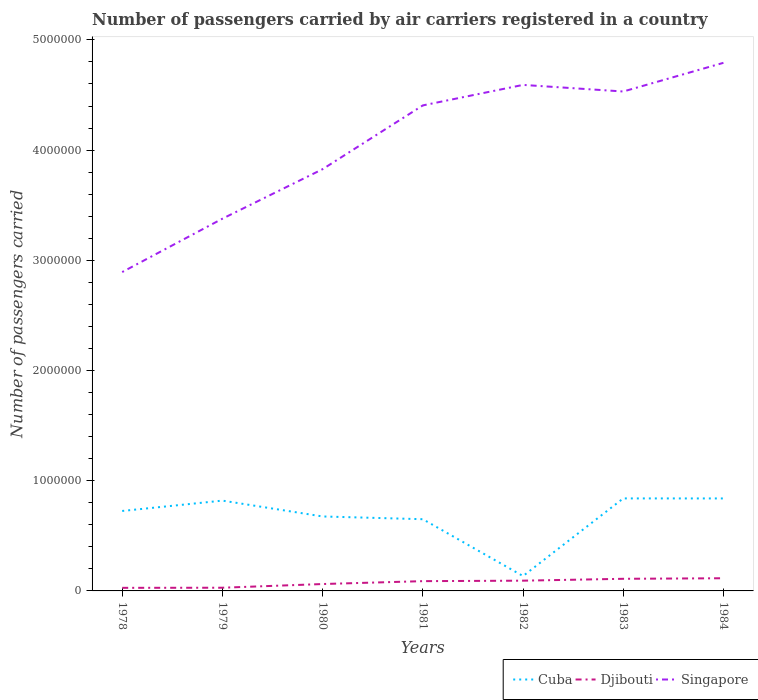Is the number of lines equal to the number of legend labels?
Your answer should be very brief. Yes. Across all years, what is the maximum number of passengers carried by air carriers in Cuba?
Provide a succinct answer. 1.35e+05. What is the total number of passengers carried by air carriers in Singapore in the graph?
Offer a terse response. -1.03e+06. What is the difference between the highest and the second highest number of passengers carried by air carriers in Djibouti?
Keep it short and to the point. 8.70e+04. Is the number of passengers carried by air carriers in Singapore strictly greater than the number of passengers carried by air carriers in Cuba over the years?
Your answer should be compact. No. How many lines are there?
Your answer should be compact. 3. Are the values on the major ticks of Y-axis written in scientific E-notation?
Provide a short and direct response. No. Does the graph contain grids?
Offer a terse response. No. How many legend labels are there?
Give a very brief answer. 3. What is the title of the graph?
Your response must be concise. Number of passengers carried by air carriers registered in a country. Does "St. Martin (French part)" appear as one of the legend labels in the graph?
Make the answer very short. No. What is the label or title of the Y-axis?
Your response must be concise. Number of passengers carried. What is the Number of passengers carried in Cuba in 1978?
Give a very brief answer. 7.26e+05. What is the Number of passengers carried of Djibouti in 1978?
Your answer should be very brief. 2.80e+04. What is the Number of passengers carried of Singapore in 1978?
Offer a very short reply. 2.89e+06. What is the Number of passengers carried of Cuba in 1979?
Make the answer very short. 8.19e+05. What is the Number of passengers carried of Djibouti in 1979?
Provide a succinct answer. 2.90e+04. What is the Number of passengers carried in Singapore in 1979?
Your answer should be compact. 3.38e+06. What is the Number of passengers carried in Cuba in 1980?
Keep it short and to the point. 6.76e+05. What is the Number of passengers carried in Djibouti in 1980?
Make the answer very short. 6.25e+04. What is the Number of passengers carried in Singapore in 1980?
Your answer should be compact. 3.83e+06. What is the Number of passengers carried in Cuba in 1981?
Give a very brief answer. 6.51e+05. What is the Number of passengers carried in Djibouti in 1981?
Make the answer very short. 8.87e+04. What is the Number of passengers carried of Singapore in 1981?
Your answer should be compact. 4.41e+06. What is the Number of passengers carried in Cuba in 1982?
Your response must be concise. 1.35e+05. What is the Number of passengers carried in Djibouti in 1982?
Your response must be concise. 9.30e+04. What is the Number of passengers carried of Singapore in 1982?
Offer a very short reply. 4.59e+06. What is the Number of passengers carried in Cuba in 1983?
Keep it short and to the point. 8.39e+05. What is the Number of passengers carried in Singapore in 1983?
Offer a terse response. 4.53e+06. What is the Number of passengers carried of Cuba in 1984?
Provide a succinct answer. 8.39e+05. What is the Number of passengers carried in Djibouti in 1984?
Give a very brief answer. 1.15e+05. What is the Number of passengers carried in Singapore in 1984?
Keep it short and to the point. 4.79e+06. Across all years, what is the maximum Number of passengers carried in Cuba?
Ensure brevity in your answer.  8.39e+05. Across all years, what is the maximum Number of passengers carried of Djibouti?
Your response must be concise. 1.15e+05. Across all years, what is the maximum Number of passengers carried in Singapore?
Give a very brief answer. 4.79e+06. Across all years, what is the minimum Number of passengers carried of Cuba?
Provide a short and direct response. 1.35e+05. Across all years, what is the minimum Number of passengers carried of Djibouti?
Your answer should be very brief. 2.80e+04. Across all years, what is the minimum Number of passengers carried in Singapore?
Give a very brief answer. 2.89e+06. What is the total Number of passengers carried in Cuba in the graph?
Provide a succinct answer. 4.68e+06. What is the total Number of passengers carried in Djibouti in the graph?
Offer a very short reply. 5.26e+05. What is the total Number of passengers carried in Singapore in the graph?
Provide a short and direct response. 2.84e+07. What is the difference between the Number of passengers carried of Cuba in 1978 and that in 1979?
Provide a succinct answer. -9.39e+04. What is the difference between the Number of passengers carried of Djibouti in 1978 and that in 1979?
Give a very brief answer. -1000. What is the difference between the Number of passengers carried of Singapore in 1978 and that in 1979?
Your answer should be compact. -4.84e+05. What is the difference between the Number of passengers carried in Cuba in 1978 and that in 1980?
Offer a terse response. 4.99e+04. What is the difference between the Number of passengers carried in Djibouti in 1978 and that in 1980?
Offer a very short reply. -3.45e+04. What is the difference between the Number of passengers carried of Singapore in 1978 and that in 1980?
Give a very brief answer. -9.34e+05. What is the difference between the Number of passengers carried of Cuba in 1978 and that in 1981?
Your answer should be very brief. 7.48e+04. What is the difference between the Number of passengers carried of Djibouti in 1978 and that in 1981?
Your answer should be compact. -6.07e+04. What is the difference between the Number of passengers carried of Singapore in 1978 and that in 1981?
Give a very brief answer. -1.51e+06. What is the difference between the Number of passengers carried of Cuba in 1978 and that in 1982?
Make the answer very short. 5.90e+05. What is the difference between the Number of passengers carried of Djibouti in 1978 and that in 1982?
Offer a very short reply. -6.50e+04. What is the difference between the Number of passengers carried in Singapore in 1978 and that in 1982?
Your answer should be very brief. -1.70e+06. What is the difference between the Number of passengers carried of Cuba in 1978 and that in 1983?
Your answer should be very brief. -1.14e+05. What is the difference between the Number of passengers carried of Djibouti in 1978 and that in 1983?
Offer a very short reply. -8.20e+04. What is the difference between the Number of passengers carried of Singapore in 1978 and that in 1983?
Provide a succinct answer. -1.64e+06. What is the difference between the Number of passengers carried of Cuba in 1978 and that in 1984?
Your response must be concise. -1.14e+05. What is the difference between the Number of passengers carried in Djibouti in 1978 and that in 1984?
Keep it short and to the point. -8.70e+04. What is the difference between the Number of passengers carried in Singapore in 1978 and that in 1984?
Provide a succinct answer. -1.90e+06. What is the difference between the Number of passengers carried of Cuba in 1979 and that in 1980?
Offer a terse response. 1.44e+05. What is the difference between the Number of passengers carried of Djibouti in 1979 and that in 1980?
Offer a very short reply. -3.35e+04. What is the difference between the Number of passengers carried of Singapore in 1979 and that in 1980?
Provide a succinct answer. -4.49e+05. What is the difference between the Number of passengers carried in Cuba in 1979 and that in 1981?
Keep it short and to the point. 1.69e+05. What is the difference between the Number of passengers carried in Djibouti in 1979 and that in 1981?
Your response must be concise. -5.97e+04. What is the difference between the Number of passengers carried in Singapore in 1979 and that in 1981?
Give a very brief answer. -1.03e+06. What is the difference between the Number of passengers carried in Cuba in 1979 and that in 1982?
Provide a short and direct response. 6.84e+05. What is the difference between the Number of passengers carried of Djibouti in 1979 and that in 1982?
Provide a short and direct response. -6.40e+04. What is the difference between the Number of passengers carried of Singapore in 1979 and that in 1982?
Give a very brief answer. -1.21e+06. What is the difference between the Number of passengers carried in Cuba in 1979 and that in 1983?
Provide a short and direct response. -2.00e+04. What is the difference between the Number of passengers carried in Djibouti in 1979 and that in 1983?
Your response must be concise. -8.10e+04. What is the difference between the Number of passengers carried of Singapore in 1979 and that in 1983?
Make the answer very short. -1.15e+06. What is the difference between the Number of passengers carried in Cuba in 1979 and that in 1984?
Your response must be concise. -1.97e+04. What is the difference between the Number of passengers carried of Djibouti in 1979 and that in 1984?
Make the answer very short. -8.60e+04. What is the difference between the Number of passengers carried in Singapore in 1979 and that in 1984?
Provide a short and direct response. -1.41e+06. What is the difference between the Number of passengers carried of Cuba in 1980 and that in 1981?
Your answer should be compact. 2.49e+04. What is the difference between the Number of passengers carried of Djibouti in 1980 and that in 1981?
Your answer should be compact. -2.62e+04. What is the difference between the Number of passengers carried of Singapore in 1980 and that in 1981?
Keep it short and to the point. -5.78e+05. What is the difference between the Number of passengers carried in Cuba in 1980 and that in 1982?
Provide a succinct answer. 5.41e+05. What is the difference between the Number of passengers carried of Djibouti in 1980 and that in 1982?
Your answer should be very brief. -3.05e+04. What is the difference between the Number of passengers carried in Singapore in 1980 and that in 1982?
Make the answer very short. -7.65e+05. What is the difference between the Number of passengers carried of Cuba in 1980 and that in 1983?
Your answer should be compact. -1.64e+05. What is the difference between the Number of passengers carried in Djibouti in 1980 and that in 1983?
Ensure brevity in your answer.  -4.75e+04. What is the difference between the Number of passengers carried of Singapore in 1980 and that in 1983?
Offer a very short reply. -7.05e+05. What is the difference between the Number of passengers carried of Cuba in 1980 and that in 1984?
Provide a short and direct response. -1.64e+05. What is the difference between the Number of passengers carried of Djibouti in 1980 and that in 1984?
Your response must be concise. -5.25e+04. What is the difference between the Number of passengers carried in Singapore in 1980 and that in 1984?
Your answer should be very brief. -9.65e+05. What is the difference between the Number of passengers carried in Cuba in 1981 and that in 1982?
Provide a short and direct response. 5.16e+05. What is the difference between the Number of passengers carried in Djibouti in 1981 and that in 1982?
Your answer should be compact. -4300. What is the difference between the Number of passengers carried in Singapore in 1981 and that in 1982?
Your answer should be very brief. -1.86e+05. What is the difference between the Number of passengers carried of Cuba in 1981 and that in 1983?
Keep it short and to the point. -1.89e+05. What is the difference between the Number of passengers carried in Djibouti in 1981 and that in 1983?
Provide a succinct answer. -2.13e+04. What is the difference between the Number of passengers carried of Singapore in 1981 and that in 1983?
Provide a succinct answer. -1.26e+05. What is the difference between the Number of passengers carried of Cuba in 1981 and that in 1984?
Provide a short and direct response. -1.88e+05. What is the difference between the Number of passengers carried of Djibouti in 1981 and that in 1984?
Your answer should be compact. -2.63e+04. What is the difference between the Number of passengers carried of Singapore in 1981 and that in 1984?
Ensure brevity in your answer.  -3.86e+05. What is the difference between the Number of passengers carried of Cuba in 1982 and that in 1983?
Give a very brief answer. -7.04e+05. What is the difference between the Number of passengers carried of Djibouti in 1982 and that in 1983?
Your answer should be very brief. -1.70e+04. What is the difference between the Number of passengers carried of Singapore in 1982 and that in 1983?
Provide a succinct answer. 5.99e+04. What is the difference between the Number of passengers carried in Cuba in 1982 and that in 1984?
Provide a short and direct response. -7.04e+05. What is the difference between the Number of passengers carried of Djibouti in 1982 and that in 1984?
Provide a short and direct response. -2.20e+04. What is the difference between the Number of passengers carried of Singapore in 1982 and that in 1984?
Your response must be concise. -2.00e+05. What is the difference between the Number of passengers carried in Cuba in 1983 and that in 1984?
Offer a very short reply. 300. What is the difference between the Number of passengers carried in Djibouti in 1983 and that in 1984?
Your response must be concise. -5000. What is the difference between the Number of passengers carried of Singapore in 1983 and that in 1984?
Offer a very short reply. -2.60e+05. What is the difference between the Number of passengers carried of Cuba in 1978 and the Number of passengers carried of Djibouti in 1979?
Provide a succinct answer. 6.96e+05. What is the difference between the Number of passengers carried in Cuba in 1978 and the Number of passengers carried in Singapore in 1979?
Provide a succinct answer. -2.65e+06. What is the difference between the Number of passengers carried of Djibouti in 1978 and the Number of passengers carried of Singapore in 1979?
Offer a terse response. -3.35e+06. What is the difference between the Number of passengers carried of Cuba in 1978 and the Number of passengers carried of Djibouti in 1980?
Give a very brief answer. 6.63e+05. What is the difference between the Number of passengers carried in Cuba in 1978 and the Number of passengers carried in Singapore in 1980?
Offer a very short reply. -3.10e+06. What is the difference between the Number of passengers carried of Djibouti in 1978 and the Number of passengers carried of Singapore in 1980?
Make the answer very short. -3.80e+06. What is the difference between the Number of passengers carried of Cuba in 1978 and the Number of passengers carried of Djibouti in 1981?
Offer a terse response. 6.37e+05. What is the difference between the Number of passengers carried of Cuba in 1978 and the Number of passengers carried of Singapore in 1981?
Your response must be concise. -3.68e+06. What is the difference between the Number of passengers carried in Djibouti in 1978 and the Number of passengers carried in Singapore in 1981?
Provide a short and direct response. -4.38e+06. What is the difference between the Number of passengers carried of Cuba in 1978 and the Number of passengers carried of Djibouti in 1982?
Your response must be concise. 6.32e+05. What is the difference between the Number of passengers carried in Cuba in 1978 and the Number of passengers carried in Singapore in 1982?
Keep it short and to the point. -3.87e+06. What is the difference between the Number of passengers carried in Djibouti in 1978 and the Number of passengers carried in Singapore in 1982?
Ensure brevity in your answer.  -4.56e+06. What is the difference between the Number of passengers carried of Cuba in 1978 and the Number of passengers carried of Djibouti in 1983?
Keep it short and to the point. 6.16e+05. What is the difference between the Number of passengers carried in Cuba in 1978 and the Number of passengers carried in Singapore in 1983?
Provide a succinct answer. -3.81e+06. What is the difference between the Number of passengers carried in Djibouti in 1978 and the Number of passengers carried in Singapore in 1983?
Offer a terse response. -4.50e+06. What is the difference between the Number of passengers carried of Cuba in 1978 and the Number of passengers carried of Djibouti in 1984?
Keep it short and to the point. 6.10e+05. What is the difference between the Number of passengers carried in Cuba in 1978 and the Number of passengers carried in Singapore in 1984?
Give a very brief answer. -4.07e+06. What is the difference between the Number of passengers carried of Djibouti in 1978 and the Number of passengers carried of Singapore in 1984?
Offer a very short reply. -4.76e+06. What is the difference between the Number of passengers carried of Cuba in 1979 and the Number of passengers carried of Djibouti in 1980?
Give a very brief answer. 7.57e+05. What is the difference between the Number of passengers carried of Cuba in 1979 and the Number of passengers carried of Singapore in 1980?
Offer a terse response. -3.01e+06. What is the difference between the Number of passengers carried of Djibouti in 1979 and the Number of passengers carried of Singapore in 1980?
Your answer should be compact. -3.80e+06. What is the difference between the Number of passengers carried in Cuba in 1979 and the Number of passengers carried in Djibouti in 1981?
Ensure brevity in your answer.  7.31e+05. What is the difference between the Number of passengers carried in Cuba in 1979 and the Number of passengers carried in Singapore in 1981?
Your response must be concise. -3.59e+06. What is the difference between the Number of passengers carried in Djibouti in 1979 and the Number of passengers carried in Singapore in 1981?
Make the answer very short. -4.38e+06. What is the difference between the Number of passengers carried of Cuba in 1979 and the Number of passengers carried of Djibouti in 1982?
Your answer should be compact. 7.26e+05. What is the difference between the Number of passengers carried of Cuba in 1979 and the Number of passengers carried of Singapore in 1982?
Ensure brevity in your answer.  -3.77e+06. What is the difference between the Number of passengers carried in Djibouti in 1979 and the Number of passengers carried in Singapore in 1982?
Your answer should be very brief. -4.56e+06. What is the difference between the Number of passengers carried of Cuba in 1979 and the Number of passengers carried of Djibouti in 1983?
Your response must be concise. 7.09e+05. What is the difference between the Number of passengers carried in Cuba in 1979 and the Number of passengers carried in Singapore in 1983?
Provide a short and direct response. -3.71e+06. What is the difference between the Number of passengers carried of Djibouti in 1979 and the Number of passengers carried of Singapore in 1983?
Ensure brevity in your answer.  -4.50e+06. What is the difference between the Number of passengers carried of Cuba in 1979 and the Number of passengers carried of Djibouti in 1984?
Your answer should be compact. 7.04e+05. What is the difference between the Number of passengers carried in Cuba in 1979 and the Number of passengers carried in Singapore in 1984?
Provide a succinct answer. -3.97e+06. What is the difference between the Number of passengers carried of Djibouti in 1979 and the Number of passengers carried of Singapore in 1984?
Ensure brevity in your answer.  -4.76e+06. What is the difference between the Number of passengers carried of Cuba in 1980 and the Number of passengers carried of Djibouti in 1981?
Your response must be concise. 5.87e+05. What is the difference between the Number of passengers carried in Cuba in 1980 and the Number of passengers carried in Singapore in 1981?
Make the answer very short. -3.73e+06. What is the difference between the Number of passengers carried in Djibouti in 1980 and the Number of passengers carried in Singapore in 1981?
Make the answer very short. -4.34e+06. What is the difference between the Number of passengers carried in Cuba in 1980 and the Number of passengers carried in Djibouti in 1982?
Give a very brief answer. 5.83e+05. What is the difference between the Number of passengers carried in Cuba in 1980 and the Number of passengers carried in Singapore in 1982?
Make the answer very short. -3.92e+06. What is the difference between the Number of passengers carried in Djibouti in 1980 and the Number of passengers carried in Singapore in 1982?
Provide a short and direct response. -4.53e+06. What is the difference between the Number of passengers carried in Cuba in 1980 and the Number of passengers carried in Djibouti in 1983?
Provide a succinct answer. 5.66e+05. What is the difference between the Number of passengers carried in Cuba in 1980 and the Number of passengers carried in Singapore in 1983?
Provide a short and direct response. -3.86e+06. What is the difference between the Number of passengers carried in Djibouti in 1980 and the Number of passengers carried in Singapore in 1983?
Make the answer very short. -4.47e+06. What is the difference between the Number of passengers carried in Cuba in 1980 and the Number of passengers carried in Djibouti in 1984?
Offer a terse response. 5.61e+05. What is the difference between the Number of passengers carried in Cuba in 1980 and the Number of passengers carried in Singapore in 1984?
Your response must be concise. -4.12e+06. What is the difference between the Number of passengers carried of Djibouti in 1980 and the Number of passengers carried of Singapore in 1984?
Provide a succinct answer. -4.73e+06. What is the difference between the Number of passengers carried in Cuba in 1981 and the Number of passengers carried in Djibouti in 1982?
Keep it short and to the point. 5.58e+05. What is the difference between the Number of passengers carried in Cuba in 1981 and the Number of passengers carried in Singapore in 1982?
Your answer should be very brief. -3.94e+06. What is the difference between the Number of passengers carried of Djibouti in 1981 and the Number of passengers carried of Singapore in 1982?
Offer a terse response. -4.50e+06. What is the difference between the Number of passengers carried of Cuba in 1981 and the Number of passengers carried of Djibouti in 1983?
Ensure brevity in your answer.  5.41e+05. What is the difference between the Number of passengers carried in Cuba in 1981 and the Number of passengers carried in Singapore in 1983?
Offer a terse response. -3.88e+06. What is the difference between the Number of passengers carried in Djibouti in 1981 and the Number of passengers carried in Singapore in 1983?
Offer a very short reply. -4.44e+06. What is the difference between the Number of passengers carried in Cuba in 1981 and the Number of passengers carried in Djibouti in 1984?
Offer a terse response. 5.36e+05. What is the difference between the Number of passengers carried in Cuba in 1981 and the Number of passengers carried in Singapore in 1984?
Provide a short and direct response. -4.14e+06. What is the difference between the Number of passengers carried in Djibouti in 1981 and the Number of passengers carried in Singapore in 1984?
Your answer should be very brief. -4.70e+06. What is the difference between the Number of passengers carried in Cuba in 1982 and the Number of passengers carried in Djibouti in 1983?
Offer a very short reply. 2.50e+04. What is the difference between the Number of passengers carried in Cuba in 1982 and the Number of passengers carried in Singapore in 1983?
Ensure brevity in your answer.  -4.40e+06. What is the difference between the Number of passengers carried in Djibouti in 1982 and the Number of passengers carried in Singapore in 1983?
Make the answer very short. -4.44e+06. What is the difference between the Number of passengers carried in Cuba in 1982 and the Number of passengers carried in Djibouti in 1984?
Keep it short and to the point. 2.00e+04. What is the difference between the Number of passengers carried of Cuba in 1982 and the Number of passengers carried of Singapore in 1984?
Keep it short and to the point. -4.66e+06. What is the difference between the Number of passengers carried in Djibouti in 1982 and the Number of passengers carried in Singapore in 1984?
Offer a very short reply. -4.70e+06. What is the difference between the Number of passengers carried of Cuba in 1983 and the Number of passengers carried of Djibouti in 1984?
Keep it short and to the point. 7.24e+05. What is the difference between the Number of passengers carried of Cuba in 1983 and the Number of passengers carried of Singapore in 1984?
Provide a succinct answer. -3.95e+06. What is the difference between the Number of passengers carried in Djibouti in 1983 and the Number of passengers carried in Singapore in 1984?
Your answer should be compact. -4.68e+06. What is the average Number of passengers carried of Cuba per year?
Offer a very short reply. 6.69e+05. What is the average Number of passengers carried of Djibouti per year?
Your answer should be very brief. 7.52e+04. What is the average Number of passengers carried of Singapore per year?
Your answer should be very brief. 4.06e+06. In the year 1978, what is the difference between the Number of passengers carried of Cuba and Number of passengers carried of Djibouti?
Ensure brevity in your answer.  6.98e+05. In the year 1978, what is the difference between the Number of passengers carried of Cuba and Number of passengers carried of Singapore?
Give a very brief answer. -2.17e+06. In the year 1978, what is the difference between the Number of passengers carried in Djibouti and Number of passengers carried in Singapore?
Provide a short and direct response. -2.87e+06. In the year 1979, what is the difference between the Number of passengers carried in Cuba and Number of passengers carried in Djibouti?
Your response must be concise. 7.90e+05. In the year 1979, what is the difference between the Number of passengers carried of Cuba and Number of passengers carried of Singapore?
Provide a short and direct response. -2.56e+06. In the year 1979, what is the difference between the Number of passengers carried of Djibouti and Number of passengers carried of Singapore?
Ensure brevity in your answer.  -3.35e+06. In the year 1980, what is the difference between the Number of passengers carried in Cuba and Number of passengers carried in Djibouti?
Your answer should be very brief. 6.13e+05. In the year 1980, what is the difference between the Number of passengers carried in Cuba and Number of passengers carried in Singapore?
Provide a succinct answer. -3.15e+06. In the year 1980, what is the difference between the Number of passengers carried of Djibouti and Number of passengers carried of Singapore?
Give a very brief answer. -3.76e+06. In the year 1981, what is the difference between the Number of passengers carried of Cuba and Number of passengers carried of Djibouti?
Keep it short and to the point. 5.62e+05. In the year 1981, what is the difference between the Number of passengers carried in Cuba and Number of passengers carried in Singapore?
Your response must be concise. -3.75e+06. In the year 1981, what is the difference between the Number of passengers carried in Djibouti and Number of passengers carried in Singapore?
Your answer should be very brief. -4.32e+06. In the year 1982, what is the difference between the Number of passengers carried of Cuba and Number of passengers carried of Djibouti?
Make the answer very short. 4.20e+04. In the year 1982, what is the difference between the Number of passengers carried of Cuba and Number of passengers carried of Singapore?
Give a very brief answer. -4.46e+06. In the year 1982, what is the difference between the Number of passengers carried in Djibouti and Number of passengers carried in Singapore?
Provide a succinct answer. -4.50e+06. In the year 1983, what is the difference between the Number of passengers carried of Cuba and Number of passengers carried of Djibouti?
Keep it short and to the point. 7.29e+05. In the year 1983, what is the difference between the Number of passengers carried of Cuba and Number of passengers carried of Singapore?
Provide a succinct answer. -3.69e+06. In the year 1983, what is the difference between the Number of passengers carried in Djibouti and Number of passengers carried in Singapore?
Give a very brief answer. -4.42e+06. In the year 1984, what is the difference between the Number of passengers carried of Cuba and Number of passengers carried of Djibouti?
Your response must be concise. 7.24e+05. In the year 1984, what is the difference between the Number of passengers carried in Cuba and Number of passengers carried in Singapore?
Your answer should be very brief. -3.95e+06. In the year 1984, what is the difference between the Number of passengers carried of Djibouti and Number of passengers carried of Singapore?
Provide a succinct answer. -4.68e+06. What is the ratio of the Number of passengers carried in Cuba in 1978 to that in 1979?
Give a very brief answer. 0.89. What is the ratio of the Number of passengers carried of Djibouti in 1978 to that in 1979?
Your response must be concise. 0.97. What is the ratio of the Number of passengers carried in Singapore in 1978 to that in 1979?
Provide a short and direct response. 0.86. What is the ratio of the Number of passengers carried of Cuba in 1978 to that in 1980?
Your answer should be very brief. 1.07. What is the ratio of the Number of passengers carried in Djibouti in 1978 to that in 1980?
Offer a very short reply. 0.45. What is the ratio of the Number of passengers carried in Singapore in 1978 to that in 1980?
Make the answer very short. 0.76. What is the ratio of the Number of passengers carried of Cuba in 1978 to that in 1981?
Your answer should be compact. 1.11. What is the ratio of the Number of passengers carried of Djibouti in 1978 to that in 1981?
Provide a succinct answer. 0.32. What is the ratio of the Number of passengers carried in Singapore in 1978 to that in 1981?
Keep it short and to the point. 0.66. What is the ratio of the Number of passengers carried in Cuba in 1978 to that in 1982?
Provide a succinct answer. 5.37. What is the ratio of the Number of passengers carried of Djibouti in 1978 to that in 1982?
Your answer should be very brief. 0.3. What is the ratio of the Number of passengers carried of Singapore in 1978 to that in 1982?
Make the answer very short. 0.63. What is the ratio of the Number of passengers carried of Cuba in 1978 to that in 1983?
Offer a terse response. 0.86. What is the ratio of the Number of passengers carried in Djibouti in 1978 to that in 1983?
Provide a succinct answer. 0.25. What is the ratio of the Number of passengers carried in Singapore in 1978 to that in 1983?
Offer a very short reply. 0.64. What is the ratio of the Number of passengers carried in Cuba in 1978 to that in 1984?
Your answer should be compact. 0.86. What is the ratio of the Number of passengers carried in Djibouti in 1978 to that in 1984?
Your response must be concise. 0.24. What is the ratio of the Number of passengers carried of Singapore in 1978 to that in 1984?
Offer a terse response. 0.6. What is the ratio of the Number of passengers carried of Cuba in 1979 to that in 1980?
Provide a succinct answer. 1.21. What is the ratio of the Number of passengers carried of Djibouti in 1979 to that in 1980?
Ensure brevity in your answer.  0.46. What is the ratio of the Number of passengers carried in Singapore in 1979 to that in 1980?
Your answer should be compact. 0.88. What is the ratio of the Number of passengers carried of Cuba in 1979 to that in 1981?
Your response must be concise. 1.26. What is the ratio of the Number of passengers carried in Djibouti in 1979 to that in 1981?
Your answer should be compact. 0.33. What is the ratio of the Number of passengers carried of Singapore in 1979 to that in 1981?
Provide a short and direct response. 0.77. What is the ratio of the Number of passengers carried in Cuba in 1979 to that in 1982?
Make the answer very short. 6.07. What is the ratio of the Number of passengers carried in Djibouti in 1979 to that in 1982?
Your answer should be compact. 0.31. What is the ratio of the Number of passengers carried of Singapore in 1979 to that in 1982?
Offer a very short reply. 0.74. What is the ratio of the Number of passengers carried of Cuba in 1979 to that in 1983?
Offer a very short reply. 0.98. What is the ratio of the Number of passengers carried of Djibouti in 1979 to that in 1983?
Give a very brief answer. 0.26. What is the ratio of the Number of passengers carried in Singapore in 1979 to that in 1983?
Your answer should be compact. 0.75. What is the ratio of the Number of passengers carried of Cuba in 1979 to that in 1984?
Offer a very short reply. 0.98. What is the ratio of the Number of passengers carried of Djibouti in 1979 to that in 1984?
Your response must be concise. 0.25. What is the ratio of the Number of passengers carried of Singapore in 1979 to that in 1984?
Ensure brevity in your answer.  0.7. What is the ratio of the Number of passengers carried in Cuba in 1980 to that in 1981?
Make the answer very short. 1.04. What is the ratio of the Number of passengers carried in Djibouti in 1980 to that in 1981?
Provide a short and direct response. 0.7. What is the ratio of the Number of passengers carried of Singapore in 1980 to that in 1981?
Your answer should be compact. 0.87. What is the ratio of the Number of passengers carried in Cuba in 1980 to that in 1982?
Your answer should be very brief. 5. What is the ratio of the Number of passengers carried of Djibouti in 1980 to that in 1982?
Keep it short and to the point. 0.67. What is the ratio of the Number of passengers carried in Singapore in 1980 to that in 1982?
Give a very brief answer. 0.83. What is the ratio of the Number of passengers carried in Cuba in 1980 to that in 1983?
Your answer should be compact. 0.8. What is the ratio of the Number of passengers carried of Djibouti in 1980 to that in 1983?
Provide a succinct answer. 0.57. What is the ratio of the Number of passengers carried of Singapore in 1980 to that in 1983?
Give a very brief answer. 0.84. What is the ratio of the Number of passengers carried in Cuba in 1980 to that in 1984?
Your answer should be compact. 0.81. What is the ratio of the Number of passengers carried in Djibouti in 1980 to that in 1984?
Ensure brevity in your answer.  0.54. What is the ratio of the Number of passengers carried of Singapore in 1980 to that in 1984?
Offer a terse response. 0.8. What is the ratio of the Number of passengers carried in Cuba in 1981 to that in 1982?
Provide a short and direct response. 4.82. What is the ratio of the Number of passengers carried in Djibouti in 1981 to that in 1982?
Your answer should be compact. 0.95. What is the ratio of the Number of passengers carried of Singapore in 1981 to that in 1982?
Provide a short and direct response. 0.96. What is the ratio of the Number of passengers carried of Cuba in 1981 to that in 1983?
Ensure brevity in your answer.  0.78. What is the ratio of the Number of passengers carried of Djibouti in 1981 to that in 1983?
Keep it short and to the point. 0.81. What is the ratio of the Number of passengers carried of Singapore in 1981 to that in 1983?
Your answer should be compact. 0.97. What is the ratio of the Number of passengers carried of Cuba in 1981 to that in 1984?
Make the answer very short. 0.78. What is the ratio of the Number of passengers carried in Djibouti in 1981 to that in 1984?
Provide a short and direct response. 0.77. What is the ratio of the Number of passengers carried of Singapore in 1981 to that in 1984?
Your answer should be very brief. 0.92. What is the ratio of the Number of passengers carried of Cuba in 1982 to that in 1983?
Your answer should be compact. 0.16. What is the ratio of the Number of passengers carried of Djibouti in 1982 to that in 1983?
Keep it short and to the point. 0.85. What is the ratio of the Number of passengers carried of Singapore in 1982 to that in 1983?
Your answer should be very brief. 1.01. What is the ratio of the Number of passengers carried of Cuba in 1982 to that in 1984?
Offer a very short reply. 0.16. What is the ratio of the Number of passengers carried of Djibouti in 1982 to that in 1984?
Your answer should be very brief. 0.81. What is the ratio of the Number of passengers carried in Singapore in 1982 to that in 1984?
Your response must be concise. 0.96. What is the ratio of the Number of passengers carried in Djibouti in 1983 to that in 1984?
Ensure brevity in your answer.  0.96. What is the ratio of the Number of passengers carried of Singapore in 1983 to that in 1984?
Offer a very short reply. 0.95. What is the difference between the highest and the second highest Number of passengers carried of Cuba?
Provide a short and direct response. 300. What is the difference between the highest and the second highest Number of passengers carried of Singapore?
Offer a very short reply. 2.00e+05. What is the difference between the highest and the lowest Number of passengers carried in Cuba?
Make the answer very short. 7.04e+05. What is the difference between the highest and the lowest Number of passengers carried in Djibouti?
Offer a very short reply. 8.70e+04. What is the difference between the highest and the lowest Number of passengers carried in Singapore?
Give a very brief answer. 1.90e+06. 